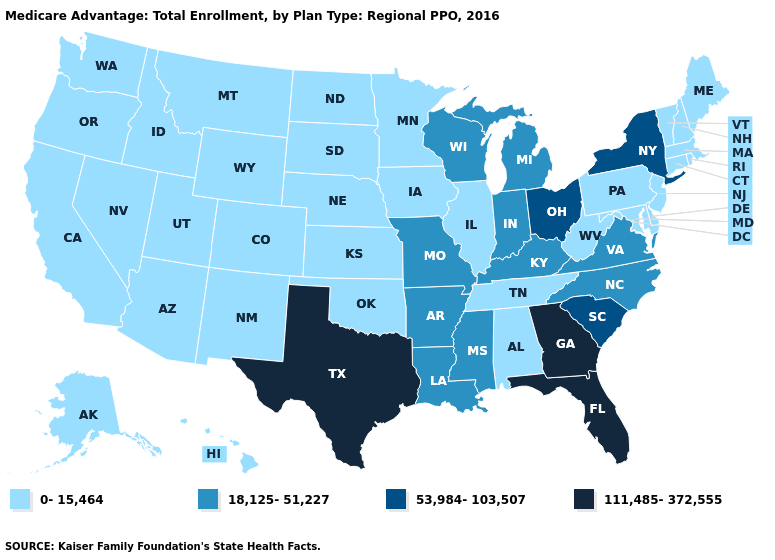What is the value of Tennessee?
Be succinct. 0-15,464. What is the lowest value in the USA?
Keep it brief. 0-15,464. Does Florida have the highest value in the USA?
Give a very brief answer. Yes. Does Wisconsin have a lower value than Iowa?
Short answer required. No. Which states hav the highest value in the Northeast?
Answer briefly. New York. Does Arkansas have the highest value in the South?
Write a very short answer. No. What is the value of Texas?
Keep it brief. 111,485-372,555. Which states hav the highest value in the South?
Write a very short answer. Florida, Georgia, Texas. What is the value of West Virginia?
Quick response, please. 0-15,464. What is the lowest value in states that border New Jersey?
Write a very short answer. 0-15,464. Is the legend a continuous bar?
Quick response, please. No. Does Georgia have the highest value in the USA?
Be succinct. Yes. What is the highest value in the USA?
Concise answer only. 111,485-372,555. Which states hav the highest value in the South?
Give a very brief answer. Florida, Georgia, Texas. 